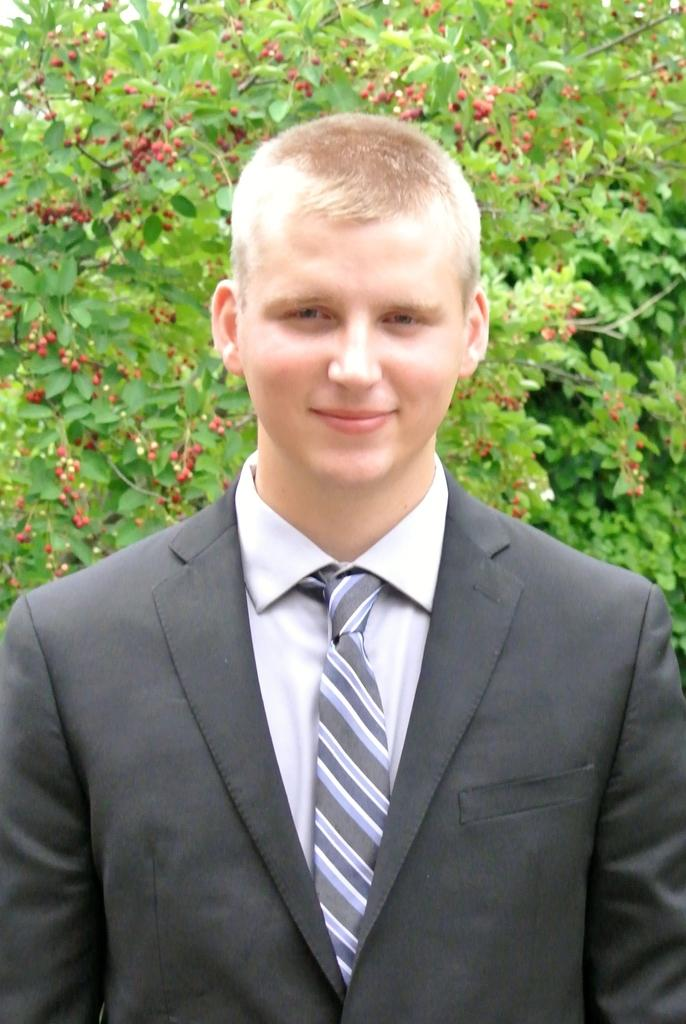Who is present in the image? There is a person in the image. What is the person wearing? The person is wearing a suit and tie. What type of plant can be seen in the image? There is a tree visible in the image. What are the characteristics of the tree? The tree has leaves and fruits. What type of sugar is being harvested from the tree in the image? There is no sugar being harvested from the tree in the image; the tree has fruits, not sugar. How does the society depicted in the image view the person's attire? The image does not depict a society or provide any context for how the person's attire might be viewed. --- Facts: 1. There is a car in the image. 2. The car is red. 3. The car has four wheels. 4. There is a road in the image. 5. The road is paved. Absurd Topics: ocean, bird, mountain Conversation: What is the main subject of the image? The main subject of the image is a car. What color is the car? The car is red. How many wheels does the car have? The car has four wheels. What type of surface can be seen in the image? There is a road in the image, and it is paved. Reasoning: Let's think step by step in order to produce the conversation. We start by identifying the main subject in the image, which is the car. Then, we describe the car's color and the number of wheels it has. Next, we shift our attention to the road, noting its presence and paved surface. Each question is designed to elicit a specific detail about the image that is known from the provided facts. Absurd Question/Answer: Can you see any ocean waves crashing against the mountain in the image? There is no ocean or mountain present in the image; it features a red car on a paved road. What type of bird is perched on the car's hood in the image? There is no bird present on the car's hood in the image. 